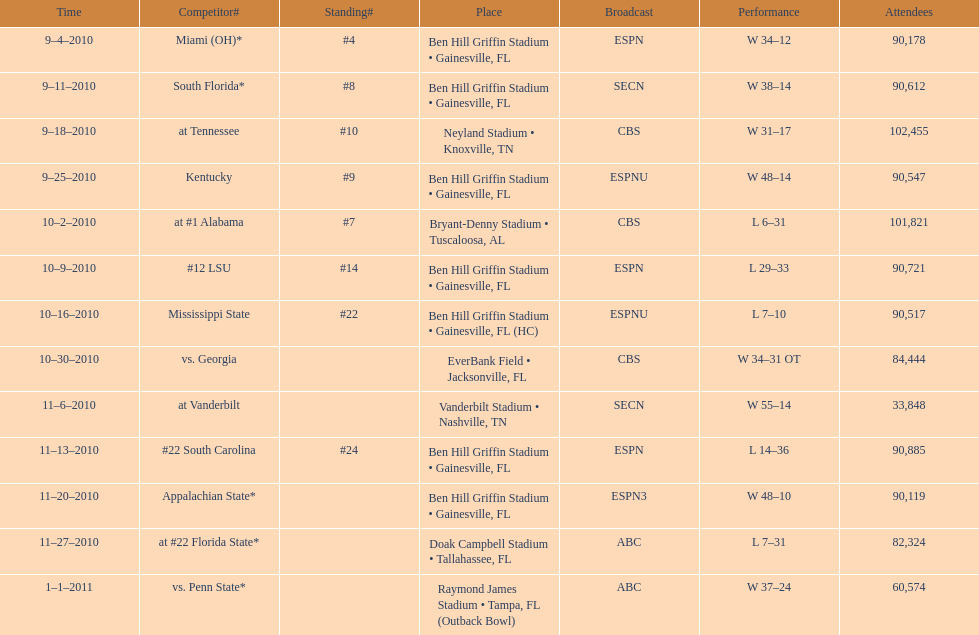How many games were played at the ben hill griffin stadium during the 2010-2011 season? 7. 